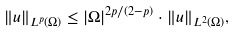<formula> <loc_0><loc_0><loc_500><loc_500>\| u \| _ { L ^ { p } ( \Omega ) } \leq | \Omega | ^ { 2 p / ( 2 - p ) } \cdot \| u \| _ { L ^ { 2 } ( \Omega ) } ,</formula> 